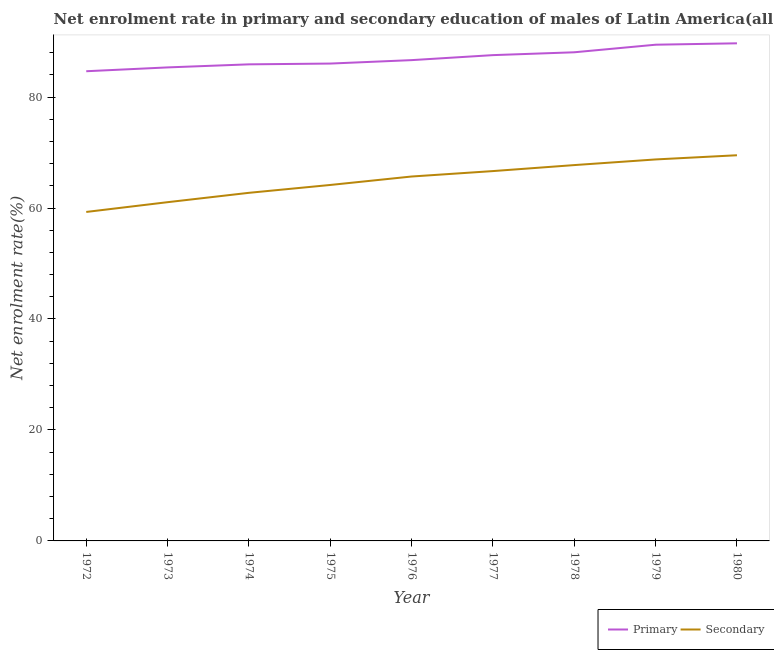Does the line corresponding to enrollment rate in primary education intersect with the line corresponding to enrollment rate in secondary education?
Provide a short and direct response. No. What is the enrollment rate in secondary education in 1978?
Make the answer very short. 67.74. Across all years, what is the maximum enrollment rate in secondary education?
Give a very brief answer. 69.51. Across all years, what is the minimum enrollment rate in primary education?
Ensure brevity in your answer.  84.65. What is the total enrollment rate in secondary education in the graph?
Offer a terse response. 585.57. What is the difference between the enrollment rate in secondary education in 1973 and that in 1978?
Keep it short and to the point. -6.68. What is the difference between the enrollment rate in secondary education in 1976 and the enrollment rate in primary education in 1979?
Offer a very short reply. -23.76. What is the average enrollment rate in secondary education per year?
Ensure brevity in your answer.  65.06. In the year 1973, what is the difference between the enrollment rate in secondary education and enrollment rate in primary education?
Your answer should be very brief. -24.29. In how many years, is the enrollment rate in secondary education greater than 76 %?
Make the answer very short. 0. What is the ratio of the enrollment rate in secondary education in 1977 to that in 1980?
Keep it short and to the point. 0.96. Is the enrollment rate in primary education in 1975 less than that in 1978?
Your answer should be very brief. Yes. Is the difference between the enrollment rate in primary education in 1975 and 1978 greater than the difference between the enrollment rate in secondary education in 1975 and 1978?
Provide a succinct answer. Yes. What is the difference between the highest and the second highest enrollment rate in primary education?
Keep it short and to the point. 0.25. What is the difference between the highest and the lowest enrollment rate in primary education?
Your response must be concise. 5.03. Does the enrollment rate in secondary education monotonically increase over the years?
Ensure brevity in your answer.  Yes. What is the difference between two consecutive major ticks on the Y-axis?
Keep it short and to the point. 20. Are the values on the major ticks of Y-axis written in scientific E-notation?
Offer a very short reply. No. Does the graph contain any zero values?
Ensure brevity in your answer.  No. Where does the legend appear in the graph?
Your response must be concise. Bottom right. How many legend labels are there?
Offer a very short reply. 2. What is the title of the graph?
Your answer should be very brief. Net enrolment rate in primary and secondary education of males of Latin America(all income levels). Does "Diesel" appear as one of the legend labels in the graph?
Your answer should be very brief. No. What is the label or title of the X-axis?
Ensure brevity in your answer.  Year. What is the label or title of the Y-axis?
Give a very brief answer. Net enrolment rate(%). What is the Net enrolment rate(%) of Primary in 1972?
Give a very brief answer. 84.65. What is the Net enrolment rate(%) in Secondary in 1972?
Your response must be concise. 59.29. What is the Net enrolment rate(%) of Primary in 1973?
Your answer should be compact. 85.34. What is the Net enrolment rate(%) in Secondary in 1973?
Provide a succinct answer. 61.05. What is the Net enrolment rate(%) in Primary in 1974?
Offer a very short reply. 85.89. What is the Net enrolment rate(%) in Secondary in 1974?
Give a very brief answer. 62.74. What is the Net enrolment rate(%) of Primary in 1975?
Your answer should be compact. 86.03. What is the Net enrolment rate(%) in Secondary in 1975?
Your answer should be very brief. 64.15. What is the Net enrolment rate(%) of Primary in 1976?
Offer a very short reply. 86.65. What is the Net enrolment rate(%) in Secondary in 1976?
Ensure brevity in your answer.  65.68. What is the Net enrolment rate(%) of Primary in 1977?
Provide a succinct answer. 87.56. What is the Net enrolment rate(%) in Secondary in 1977?
Ensure brevity in your answer.  66.66. What is the Net enrolment rate(%) of Primary in 1978?
Offer a terse response. 88.07. What is the Net enrolment rate(%) in Secondary in 1978?
Make the answer very short. 67.74. What is the Net enrolment rate(%) of Primary in 1979?
Offer a terse response. 89.43. What is the Net enrolment rate(%) in Secondary in 1979?
Offer a terse response. 68.75. What is the Net enrolment rate(%) in Primary in 1980?
Make the answer very short. 89.68. What is the Net enrolment rate(%) of Secondary in 1980?
Provide a succinct answer. 69.51. Across all years, what is the maximum Net enrolment rate(%) of Primary?
Offer a very short reply. 89.68. Across all years, what is the maximum Net enrolment rate(%) of Secondary?
Make the answer very short. 69.51. Across all years, what is the minimum Net enrolment rate(%) in Primary?
Your answer should be very brief. 84.65. Across all years, what is the minimum Net enrolment rate(%) of Secondary?
Keep it short and to the point. 59.29. What is the total Net enrolment rate(%) of Primary in the graph?
Make the answer very short. 783.32. What is the total Net enrolment rate(%) of Secondary in the graph?
Keep it short and to the point. 585.57. What is the difference between the Net enrolment rate(%) in Primary in 1972 and that in 1973?
Keep it short and to the point. -0.69. What is the difference between the Net enrolment rate(%) in Secondary in 1972 and that in 1973?
Provide a short and direct response. -1.76. What is the difference between the Net enrolment rate(%) of Primary in 1972 and that in 1974?
Provide a succinct answer. -1.24. What is the difference between the Net enrolment rate(%) of Secondary in 1972 and that in 1974?
Your answer should be compact. -3.45. What is the difference between the Net enrolment rate(%) of Primary in 1972 and that in 1975?
Offer a terse response. -1.38. What is the difference between the Net enrolment rate(%) of Secondary in 1972 and that in 1975?
Your response must be concise. -4.86. What is the difference between the Net enrolment rate(%) in Primary in 1972 and that in 1976?
Your response must be concise. -2. What is the difference between the Net enrolment rate(%) in Secondary in 1972 and that in 1976?
Make the answer very short. -6.39. What is the difference between the Net enrolment rate(%) of Primary in 1972 and that in 1977?
Make the answer very short. -2.9. What is the difference between the Net enrolment rate(%) in Secondary in 1972 and that in 1977?
Your answer should be compact. -7.37. What is the difference between the Net enrolment rate(%) of Primary in 1972 and that in 1978?
Offer a terse response. -3.42. What is the difference between the Net enrolment rate(%) of Secondary in 1972 and that in 1978?
Your answer should be very brief. -8.45. What is the difference between the Net enrolment rate(%) of Primary in 1972 and that in 1979?
Give a very brief answer. -4.78. What is the difference between the Net enrolment rate(%) in Secondary in 1972 and that in 1979?
Offer a terse response. -9.46. What is the difference between the Net enrolment rate(%) in Primary in 1972 and that in 1980?
Your response must be concise. -5.03. What is the difference between the Net enrolment rate(%) of Secondary in 1972 and that in 1980?
Make the answer very short. -10.22. What is the difference between the Net enrolment rate(%) in Primary in 1973 and that in 1974?
Your answer should be compact. -0.55. What is the difference between the Net enrolment rate(%) in Secondary in 1973 and that in 1974?
Your answer should be very brief. -1.69. What is the difference between the Net enrolment rate(%) of Primary in 1973 and that in 1975?
Your answer should be compact. -0.69. What is the difference between the Net enrolment rate(%) in Secondary in 1973 and that in 1975?
Provide a short and direct response. -3.1. What is the difference between the Net enrolment rate(%) in Primary in 1973 and that in 1976?
Offer a very short reply. -1.31. What is the difference between the Net enrolment rate(%) in Secondary in 1973 and that in 1976?
Provide a succinct answer. -4.63. What is the difference between the Net enrolment rate(%) of Primary in 1973 and that in 1977?
Make the answer very short. -2.21. What is the difference between the Net enrolment rate(%) of Secondary in 1973 and that in 1977?
Make the answer very short. -5.61. What is the difference between the Net enrolment rate(%) in Primary in 1973 and that in 1978?
Ensure brevity in your answer.  -2.72. What is the difference between the Net enrolment rate(%) in Secondary in 1973 and that in 1978?
Provide a short and direct response. -6.68. What is the difference between the Net enrolment rate(%) of Primary in 1973 and that in 1979?
Give a very brief answer. -4.09. What is the difference between the Net enrolment rate(%) in Secondary in 1973 and that in 1979?
Provide a short and direct response. -7.7. What is the difference between the Net enrolment rate(%) in Primary in 1973 and that in 1980?
Provide a short and direct response. -4.34. What is the difference between the Net enrolment rate(%) of Secondary in 1973 and that in 1980?
Provide a succinct answer. -8.46. What is the difference between the Net enrolment rate(%) in Primary in 1974 and that in 1975?
Give a very brief answer. -0.14. What is the difference between the Net enrolment rate(%) of Secondary in 1974 and that in 1975?
Your response must be concise. -1.42. What is the difference between the Net enrolment rate(%) in Primary in 1974 and that in 1976?
Provide a succinct answer. -0.76. What is the difference between the Net enrolment rate(%) in Secondary in 1974 and that in 1976?
Provide a short and direct response. -2.94. What is the difference between the Net enrolment rate(%) of Primary in 1974 and that in 1977?
Your answer should be compact. -1.66. What is the difference between the Net enrolment rate(%) of Secondary in 1974 and that in 1977?
Your answer should be very brief. -3.92. What is the difference between the Net enrolment rate(%) of Primary in 1974 and that in 1978?
Provide a short and direct response. -2.17. What is the difference between the Net enrolment rate(%) of Secondary in 1974 and that in 1978?
Provide a short and direct response. -5. What is the difference between the Net enrolment rate(%) in Primary in 1974 and that in 1979?
Give a very brief answer. -3.54. What is the difference between the Net enrolment rate(%) of Secondary in 1974 and that in 1979?
Keep it short and to the point. -6.02. What is the difference between the Net enrolment rate(%) of Primary in 1974 and that in 1980?
Make the answer very short. -3.79. What is the difference between the Net enrolment rate(%) of Secondary in 1974 and that in 1980?
Your answer should be compact. -6.77. What is the difference between the Net enrolment rate(%) in Primary in 1975 and that in 1976?
Make the answer very short. -0.62. What is the difference between the Net enrolment rate(%) in Secondary in 1975 and that in 1976?
Your answer should be very brief. -1.52. What is the difference between the Net enrolment rate(%) of Primary in 1975 and that in 1977?
Provide a short and direct response. -1.52. What is the difference between the Net enrolment rate(%) of Secondary in 1975 and that in 1977?
Give a very brief answer. -2.5. What is the difference between the Net enrolment rate(%) in Primary in 1975 and that in 1978?
Your answer should be very brief. -2.03. What is the difference between the Net enrolment rate(%) in Secondary in 1975 and that in 1978?
Offer a very short reply. -3.58. What is the difference between the Net enrolment rate(%) in Primary in 1975 and that in 1979?
Make the answer very short. -3.4. What is the difference between the Net enrolment rate(%) of Secondary in 1975 and that in 1979?
Ensure brevity in your answer.  -4.6. What is the difference between the Net enrolment rate(%) of Primary in 1975 and that in 1980?
Offer a terse response. -3.65. What is the difference between the Net enrolment rate(%) in Secondary in 1975 and that in 1980?
Make the answer very short. -5.35. What is the difference between the Net enrolment rate(%) of Primary in 1976 and that in 1977?
Your answer should be very brief. -0.9. What is the difference between the Net enrolment rate(%) in Secondary in 1976 and that in 1977?
Offer a very short reply. -0.98. What is the difference between the Net enrolment rate(%) of Primary in 1976 and that in 1978?
Make the answer very short. -1.41. What is the difference between the Net enrolment rate(%) in Secondary in 1976 and that in 1978?
Give a very brief answer. -2.06. What is the difference between the Net enrolment rate(%) of Primary in 1976 and that in 1979?
Make the answer very short. -2.78. What is the difference between the Net enrolment rate(%) of Secondary in 1976 and that in 1979?
Ensure brevity in your answer.  -3.08. What is the difference between the Net enrolment rate(%) in Primary in 1976 and that in 1980?
Offer a very short reply. -3.03. What is the difference between the Net enrolment rate(%) in Secondary in 1976 and that in 1980?
Ensure brevity in your answer.  -3.83. What is the difference between the Net enrolment rate(%) in Primary in 1977 and that in 1978?
Provide a succinct answer. -0.51. What is the difference between the Net enrolment rate(%) of Secondary in 1977 and that in 1978?
Your response must be concise. -1.08. What is the difference between the Net enrolment rate(%) in Primary in 1977 and that in 1979?
Provide a succinct answer. -1.88. What is the difference between the Net enrolment rate(%) in Secondary in 1977 and that in 1979?
Keep it short and to the point. -2.1. What is the difference between the Net enrolment rate(%) in Primary in 1977 and that in 1980?
Your answer should be very brief. -2.13. What is the difference between the Net enrolment rate(%) of Secondary in 1977 and that in 1980?
Ensure brevity in your answer.  -2.85. What is the difference between the Net enrolment rate(%) in Primary in 1978 and that in 1979?
Provide a short and direct response. -1.36. What is the difference between the Net enrolment rate(%) of Secondary in 1978 and that in 1979?
Ensure brevity in your answer.  -1.02. What is the difference between the Net enrolment rate(%) in Primary in 1978 and that in 1980?
Your response must be concise. -1.62. What is the difference between the Net enrolment rate(%) of Secondary in 1978 and that in 1980?
Offer a terse response. -1.77. What is the difference between the Net enrolment rate(%) in Primary in 1979 and that in 1980?
Ensure brevity in your answer.  -0.25. What is the difference between the Net enrolment rate(%) of Secondary in 1979 and that in 1980?
Make the answer very short. -0.75. What is the difference between the Net enrolment rate(%) of Primary in 1972 and the Net enrolment rate(%) of Secondary in 1973?
Make the answer very short. 23.6. What is the difference between the Net enrolment rate(%) in Primary in 1972 and the Net enrolment rate(%) in Secondary in 1974?
Make the answer very short. 21.91. What is the difference between the Net enrolment rate(%) in Primary in 1972 and the Net enrolment rate(%) in Secondary in 1975?
Provide a succinct answer. 20.5. What is the difference between the Net enrolment rate(%) of Primary in 1972 and the Net enrolment rate(%) of Secondary in 1976?
Offer a very short reply. 18.98. What is the difference between the Net enrolment rate(%) of Primary in 1972 and the Net enrolment rate(%) of Secondary in 1977?
Your response must be concise. 18. What is the difference between the Net enrolment rate(%) in Primary in 1972 and the Net enrolment rate(%) in Secondary in 1978?
Ensure brevity in your answer.  16.92. What is the difference between the Net enrolment rate(%) of Primary in 1972 and the Net enrolment rate(%) of Secondary in 1979?
Keep it short and to the point. 15.9. What is the difference between the Net enrolment rate(%) in Primary in 1972 and the Net enrolment rate(%) in Secondary in 1980?
Your answer should be very brief. 15.14. What is the difference between the Net enrolment rate(%) of Primary in 1973 and the Net enrolment rate(%) of Secondary in 1974?
Provide a short and direct response. 22.6. What is the difference between the Net enrolment rate(%) in Primary in 1973 and the Net enrolment rate(%) in Secondary in 1975?
Ensure brevity in your answer.  21.19. What is the difference between the Net enrolment rate(%) of Primary in 1973 and the Net enrolment rate(%) of Secondary in 1976?
Your answer should be very brief. 19.67. What is the difference between the Net enrolment rate(%) in Primary in 1973 and the Net enrolment rate(%) in Secondary in 1977?
Keep it short and to the point. 18.69. What is the difference between the Net enrolment rate(%) of Primary in 1973 and the Net enrolment rate(%) of Secondary in 1978?
Give a very brief answer. 17.61. What is the difference between the Net enrolment rate(%) of Primary in 1973 and the Net enrolment rate(%) of Secondary in 1979?
Offer a very short reply. 16.59. What is the difference between the Net enrolment rate(%) of Primary in 1973 and the Net enrolment rate(%) of Secondary in 1980?
Offer a terse response. 15.83. What is the difference between the Net enrolment rate(%) of Primary in 1974 and the Net enrolment rate(%) of Secondary in 1975?
Offer a very short reply. 21.74. What is the difference between the Net enrolment rate(%) in Primary in 1974 and the Net enrolment rate(%) in Secondary in 1976?
Make the answer very short. 20.22. What is the difference between the Net enrolment rate(%) of Primary in 1974 and the Net enrolment rate(%) of Secondary in 1977?
Offer a terse response. 19.24. What is the difference between the Net enrolment rate(%) of Primary in 1974 and the Net enrolment rate(%) of Secondary in 1978?
Offer a very short reply. 18.16. What is the difference between the Net enrolment rate(%) of Primary in 1974 and the Net enrolment rate(%) of Secondary in 1979?
Ensure brevity in your answer.  17.14. What is the difference between the Net enrolment rate(%) of Primary in 1974 and the Net enrolment rate(%) of Secondary in 1980?
Give a very brief answer. 16.38. What is the difference between the Net enrolment rate(%) in Primary in 1975 and the Net enrolment rate(%) in Secondary in 1976?
Ensure brevity in your answer.  20.36. What is the difference between the Net enrolment rate(%) in Primary in 1975 and the Net enrolment rate(%) in Secondary in 1977?
Make the answer very short. 19.38. What is the difference between the Net enrolment rate(%) of Primary in 1975 and the Net enrolment rate(%) of Secondary in 1978?
Your answer should be compact. 18.3. What is the difference between the Net enrolment rate(%) in Primary in 1975 and the Net enrolment rate(%) in Secondary in 1979?
Offer a very short reply. 17.28. What is the difference between the Net enrolment rate(%) of Primary in 1975 and the Net enrolment rate(%) of Secondary in 1980?
Ensure brevity in your answer.  16.53. What is the difference between the Net enrolment rate(%) in Primary in 1976 and the Net enrolment rate(%) in Secondary in 1977?
Keep it short and to the point. 20. What is the difference between the Net enrolment rate(%) of Primary in 1976 and the Net enrolment rate(%) of Secondary in 1978?
Give a very brief answer. 18.92. What is the difference between the Net enrolment rate(%) in Primary in 1976 and the Net enrolment rate(%) in Secondary in 1979?
Keep it short and to the point. 17.9. What is the difference between the Net enrolment rate(%) of Primary in 1976 and the Net enrolment rate(%) of Secondary in 1980?
Ensure brevity in your answer.  17.15. What is the difference between the Net enrolment rate(%) of Primary in 1977 and the Net enrolment rate(%) of Secondary in 1978?
Your answer should be compact. 19.82. What is the difference between the Net enrolment rate(%) in Primary in 1977 and the Net enrolment rate(%) in Secondary in 1979?
Provide a succinct answer. 18.8. What is the difference between the Net enrolment rate(%) in Primary in 1977 and the Net enrolment rate(%) in Secondary in 1980?
Your response must be concise. 18.05. What is the difference between the Net enrolment rate(%) in Primary in 1978 and the Net enrolment rate(%) in Secondary in 1979?
Keep it short and to the point. 19.31. What is the difference between the Net enrolment rate(%) in Primary in 1978 and the Net enrolment rate(%) in Secondary in 1980?
Your answer should be very brief. 18.56. What is the difference between the Net enrolment rate(%) in Primary in 1979 and the Net enrolment rate(%) in Secondary in 1980?
Provide a short and direct response. 19.92. What is the average Net enrolment rate(%) in Primary per year?
Make the answer very short. 87.04. What is the average Net enrolment rate(%) in Secondary per year?
Provide a succinct answer. 65.06. In the year 1972, what is the difference between the Net enrolment rate(%) in Primary and Net enrolment rate(%) in Secondary?
Ensure brevity in your answer.  25.36. In the year 1973, what is the difference between the Net enrolment rate(%) of Primary and Net enrolment rate(%) of Secondary?
Provide a succinct answer. 24.29. In the year 1974, what is the difference between the Net enrolment rate(%) in Primary and Net enrolment rate(%) in Secondary?
Your answer should be very brief. 23.15. In the year 1975, what is the difference between the Net enrolment rate(%) in Primary and Net enrolment rate(%) in Secondary?
Make the answer very short. 21.88. In the year 1976, what is the difference between the Net enrolment rate(%) in Primary and Net enrolment rate(%) in Secondary?
Offer a very short reply. 20.98. In the year 1977, what is the difference between the Net enrolment rate(%) of Primary and Net enrolment rate(%) of Secondary?
Your answer should be compact. 20.9. In the year 1978, what is the difference between the Net enrolment rate(%) of Primary and Net enrolment rate(%) of Secondary?
Your answer should be very brief. 20.33. In the year 1979, what is the difference between the Net enrolment rate(%) of Primary and Net enrolment rate(%) of Secondary?
Your response must be concise. 20.68. In the year 1980, what is the difference between the Net enrolment rate(%) in Primary and Net enrolment rate(%) in Secondary?
Make the answer very short. 20.18. What is the ratio of the Net enrolment rate(%) in Primary in 1972 to that in 1973?
Ensure brevity in your answer.  0.99. What is the ratio of the Net enrolment rate(%) of Secondary in 1972 to that in 1973?
Ensure brevity in your answer.  0.97. What is the ratio of the Net enrolment rate(%) in Primary in 1972 to that in 1974?
Your response must be concise. 0.99. What is the ratio of the Net enrolment rate(%) of Secondary in 1972 to that in 1974?
Your answer should be compact. 0.94. What is the ratio of the Net enrolment rate(%) in Primary in 1972 to that in 1975?
Your response must be concise. 0.98. What is the ratio of the Net enrolment rate(%) in Secondary in 1972 to that in 1975?
Your response must be concise. 0.92. What is the ratio of the Net enrolment rate(%) in Primary in 1972 to that in 1976?
Offer a terse response. 0.98. What is the ratio of the Net enrolment rate(%) of Secondary in 1972 to that in 1976?
Give a very brief answer. 0.9. What is the ratio of the Net enrolment rate(%) of Primary in 1972 to that in 1977?
Keep it short and to the point. 0.97. What is the ratio of the Net enrolment rate(%) in Secondary in 1972 to that in 1977?
Your response must be concise. 0.89. What is the ratio of the Net enrolment rate(%) of Primary in 1972 to that in 1978?
Your answer should be compact. 0.96. What is the ratio of the Net enrolment rate(%) in Secondary in 1972 to that in 1978?
Keep it short and to the point. 0.88. What is the ratio of the Net enrolment rate(%) in Primary in 1972 to that in 1979?
Provide a short and direct response. 0.95. What is the ratio of the Net enrolment rate(%) of Secondary in 1972 to that in 1979?
Ensure brevity in your answer.  0.86. What is the ratio of the Net enrolment rate(%) in Primary in 1972 to that in 1980?
Ensure brevity in your answer.  0.94. What is the ratio of the Net enrolment rate(%) in Secondary in 1972 to that in 1980?
Provide a succinct answer. 0.85. What is the ratio of the Net enrolment rate(%) of Primary in 1973 to that in 1974?
Your answer should be compact. 0.99. What is the ratio of the Net enrolment rate(%) of Secondary in 1973 to that in 1974?
Provide a short and direct response. 0.97. What is the ratio of the Net enrolment rate(%) of Secondary in 1973 to that in 1975?
Ensure brevity in your answer.  0.95. What is the ratio of the Net enrolment rate(%) in Primary in 1973 to that in 1976?
Provide a succinct answer. 0.98. What is the ratio of the Net enrolment rate(%) of Secondary in 1973 to that in 1976?
Keep it short and to the point. 0.93. What is the ratio of the Net enrolment rate(%) of Primary in 1973 to that in 1977?
Your answer should be very brief. 0.97. What is the ratio of the Net enrolment rate(%) in Secondary in 1973 to that in 1977?
Your response must be concise. 0.92. What is the ratio of the Net enrolment rate(%) in Primary in 1973 to that in 1978?
Your answer should be very brief. 0.97. What is the ratio of the Net enrolment rate(%) of Secondary in 1973 to that in 1978?
Your answer should be very brief. 0.9. What is the ratio of the Net enrolment rate(%) in Primary in 1973 to that in 1979?
Keep it short and to the point. 0.95. What is the ratio of the Net enrolment rate(%) of Secondary in 1973 to that in 1979?
Give a very brief answer. 0.89. What is the ratio of the Net enrolment rate(%) in Primary in 1973 to that in 1980?
Your answer should be compact. 0.95. What is the ratio of the Net enrolment rate(%) of Secondary in 1973 to that in 1980?
Ensure brevity in your answer.  0.88. What is the ratio of the Net enrolment rate(%) in Secondary in 1974 to that in 1975?
Your answer should be very brief. 0.98. What is the ratio of the Net enrolment rate(%) of Primary in 1974 to that in 1976?
Provide a succinct answer. 0.99. What is the ratio of the Net enrolment rate(%) in Secondary in 1974 to that in 1976?
Your answer should be very brief. 0.96. What is the ratio of the Net enrolment rate(%) of Primary in 1974 to that in 1977?
Provide a short and direct response. 0.98. What is the ratio of the Net enrolment rate(%) of Secondary in 1974 to that in 1977?
Your answer should be very brief. 0.94. What is the ratio of the Net enrolment rate(%) in Primary in 1974 to that in 1978?
Provide a succinct answer. 0.98. What is the ratio of the Net enrolment rate(%) of Secondary in 1974 to that in 1978?
Make the answer very short. 0.93. What is the ratio of the Net enrolment rate(%) in Primary in 1974 to that in 1979?
Provide a succinct answer. 0.96. What is the ratio of the Net enrolment rate(%) of Secondary in 1974 to that in 1979?
Your response must be concise. 0.91. What is the ratio of the Net enrolment rate(%) of Primary in 1974 to that in 1980?
Give a very brief answer. 0.96. What is the ratio of the Net enrolment rate(%) of Secondary in 1974 to that in 1980?
Keep it short and to the point. 0.9. What is the ratio of the Net enrolment rate(%) of Primary in 1975 to that in 1976?
Your answer should be compact. 0.99. What is the ratio of the Net enrolment rate(%) of Secondary in 1975 to that in 1976?
Your answer should be compact. 0.98. What is the ratio of the Net enrolment rate(%) in Primary in 1975 to that in 1977?
Ensure brevity in your answer.  0.98. What is the ratio of the Net enrolment rate(%) of Secondary in 1975 to that in 1977?
Ensure brevity in your answer.  0.96. What is the ratio of the Net enrolment rate(%) of Primary in 1975 to that in 1978?
Provide a short and direct response. 0.98. What is the ratio of the Net enrolment rate(%) in Secondary in 1975 to that in 1978?
Offer a very short reply. 0.95. What is the ratio of the Net enrolment rate(%) in Primary in 1975 to that in 1979?
Keep it short and to the point. 0.96. What is the ratio of the Net enrolment rate(%) of Secondary in 1975 to that in 1979?
Offer a very short reply. 0.93. What is the ratio of the Net enrolment rate(%) in Primary in 1975 to that in 1980?
Offer a very short reply. 0.96. What is the ratio of the Net enrolment rate(%) of Secondary in 1975 to that in 1980?
Keep it short and to the point. 0.92. What is the ratio of the Net enrolment rate(%) in Secondary in 1976 to that in 1978?
Ensure brevity in your answer.  0.97. What is the ratio of the Net enrolment rate(%) of Primary in 1976 to that in 1979?
Give a very brief answer. 0.97. What is the ratio of the Net enrolment rate(%) of Secondary in 1976 to that in 1979?
Offer a very short reply. 0.96. What is the ratio of the Net enrolment rate(%) in Primary in 1976 to that in 1980?
Ensure brevity in your answer.  0.97. What is the ratio of the Net enrolment rate(%) of Secondary in 1976 to that in 1980?
Give a very brief answer. 0.94. What is the ratio of the Net enrolment rate(%) in Primary in 1977 to that in 1978?
Your answer should be compact. 0.99. What is the ratio of the Net enrolment rate(%) in Secondary in 1977 to that in 1978?
Give a very brief answer. 0.98. What is the ratio of the Net enrolment rate(%) in Secondary in 1977 to that in 1979?
Provide a succinct answer. 0.97. What is the ratio of the Net enrolment rate(%) in Primary in 1977 to that in 1980?
Provide a short and direct response. 0.98. What is the ratio of the Net enrolment rate(%) in Primary in 1978 to that in 1979?
Offer a terse response. 0.98. What is the ratio of the Net enrolment rate(%) in Secondary in 1978 to that in 1979?
Offer a terse response. 0.99. What is the ratio of the Net enrolment rate(%) in Secondary in 1978 to that in 1980?
Your response must be concise. 0.97. What is the difference between the highest and the second highest Net enrolment rate(%) of Primary?
Your answer should be very brief. 0.25. What is the difference between the highest and the second highest Net enrolment rate(%) in Secondary?
Offer a very short reply. 0.75. What is the difference between the highest and the lowest Net enrolment rate(%) in Primary?
Your answer should be compact. 5.03. What is the difference between the highest and the lowest Net enrolment rate(%) of Secondary?
Provide a short and direct response. 10.22. 